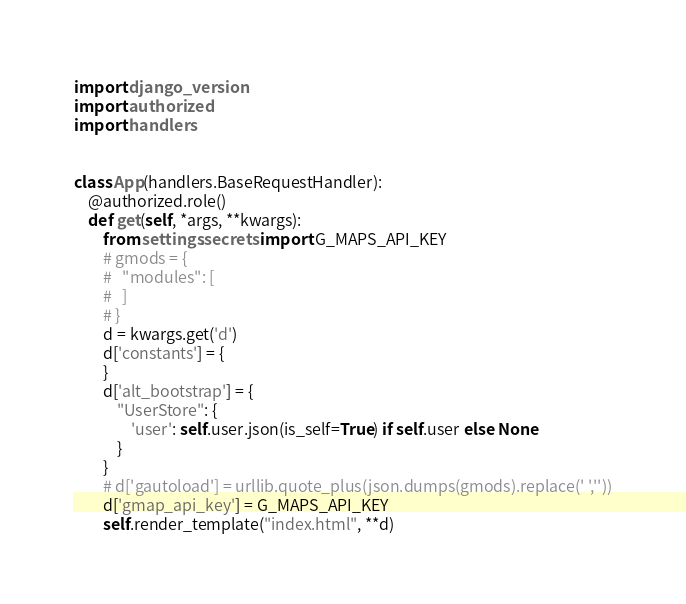Convert code to text. <code><loc_0><loc_0><loc_500><loc_500><_Python_>import django_version
import authorized
import handlers


class App(handlers.BaseRequestHandler):
    @authorized.role()
    def get(self, *args, **kwargs):
        from settings.secrets import G_MAPS_API_KEY
        # gmods = {
        #   "modules": [
        #   ]
        # }
        d = kwargs.get('d')
        d['constants'] = {
        }
        d['alt_bootstrap'] = {
            "UserStore": {
                'user': self.user.json(is_self=True) if self.user else None
            }
        }
        # d['gautoload'] = urllib.quote_plus(json.dumps(gmods).replace(' ',''))
        d['gmap_api_key'] = G_MAPS_API_KEY
        self.render_template("index.html", **d)

</code> 